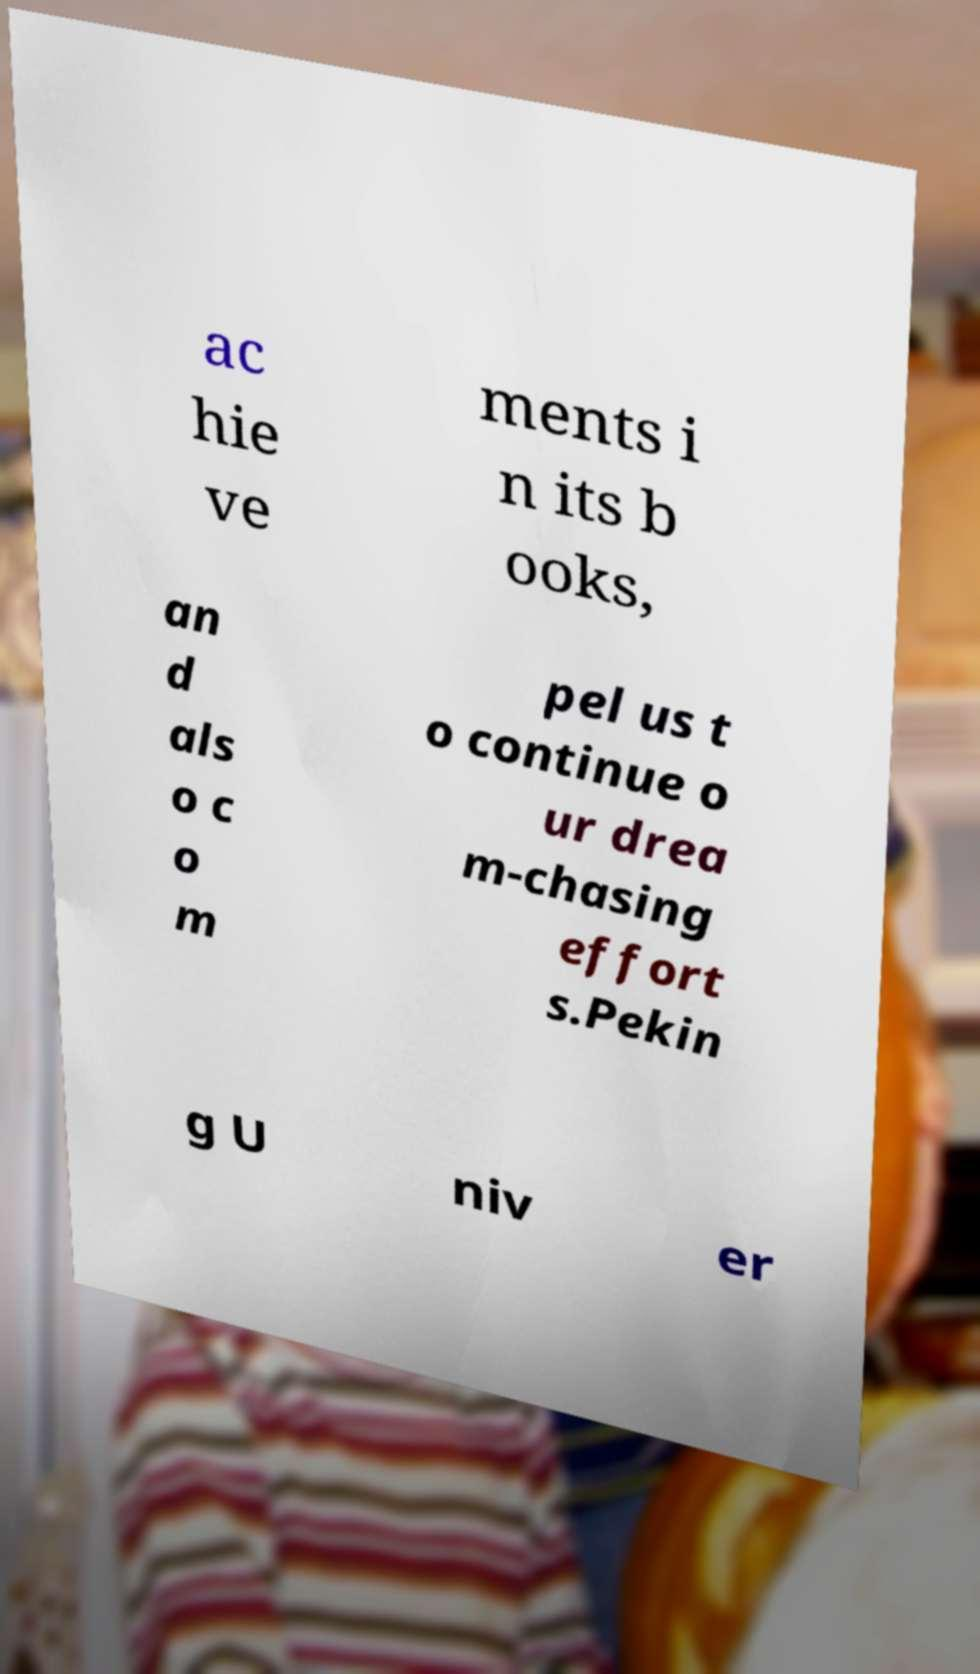Can you read and provide the text displayed in the image?This photo seems to have some interesting text. Can you extract and type it out for me? ac hie ve ments i n its b ooks, an d als o c o m pel us t o continue o ur drea m-chasing effort s.Pekin g U niv er 